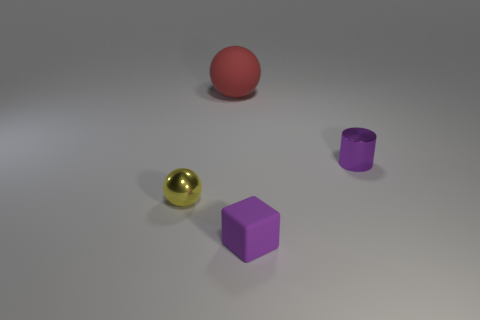What is the yellow thing made of?
Your answer should be compact. Metal. Are there more cylinders on the right side of the small metal sphere than yellow matte blocks?
Your answer should be very brief. Yes. There is a object behind the purple object to the right of the small matte cube; what number of small things are behind it?
Provide a succinct answer. 0. What material is the thing that is to the left of the small block and in front of the small cylinder?
Give a very brief answer. Metal. The small rubber block has what color?
Your answer should be very brief. Purple. Is the number of objects that are behind the purple matte object greater than the number of rubber cubes that are behind the small sphere?
Make the answer very short. Yes. There is a rubber object that is in front of the small purple metal cylinder; what color is it?
Your answer should be compact. Purple. Does the shiny thing that is behind the small yellow object have the same size as the sphere to the left of the large ball?
Ensure brevity in your answer.  Yes. How many objects are either tiny purple objects or large matte spheres?
Provide a short and direct response. 3. There is a tiny purple object on the right side of the purple matte object in front of the large red thing; what is its material?
Provide a succinct answer. Metal. 